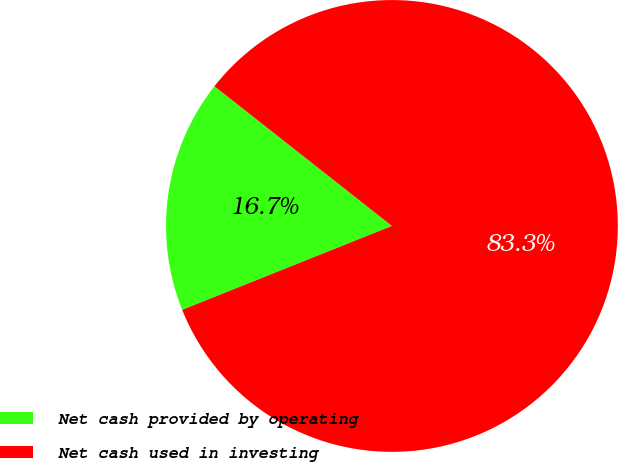<chart> <loc_0><loc_0><loc_500><loc_500><pie_chart><fcel>Net cash provided by operating<fcel>Net cash used in investing<nl><fcel>16.67%<fcel>83.33%<nl></chart> 